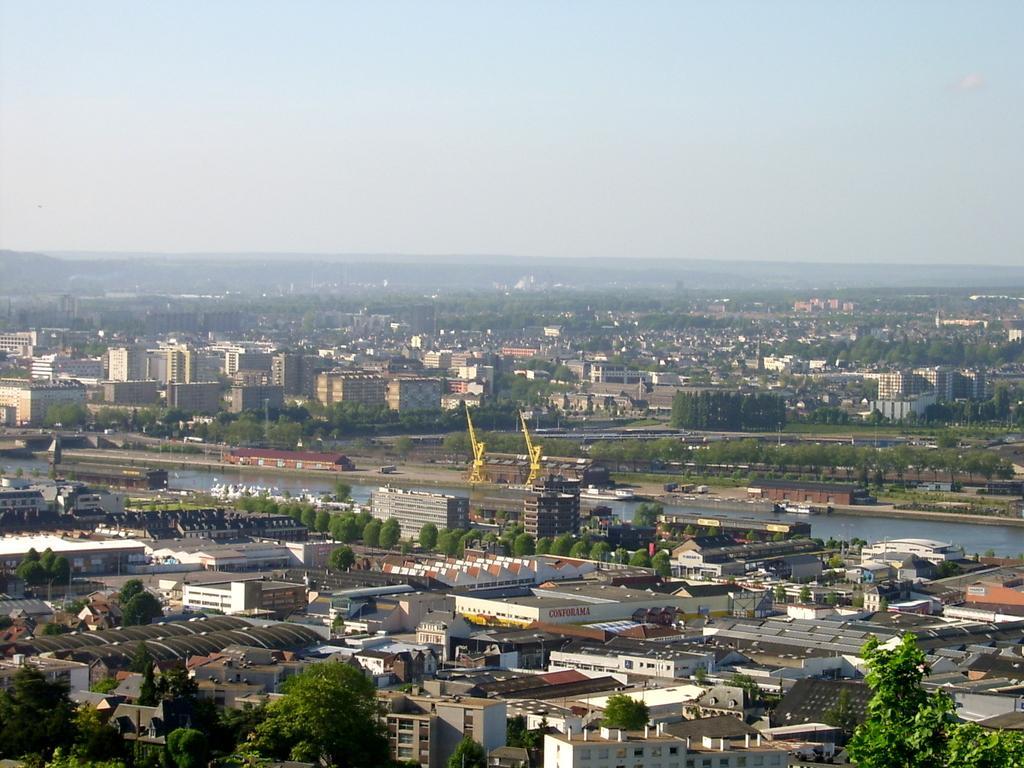In one or two sentences, can you explain what this image depicts? This is the aerial view of a city. In this image we can see trees, buildings, cranes, watersheds, poles, sign boards, hills and sky. 